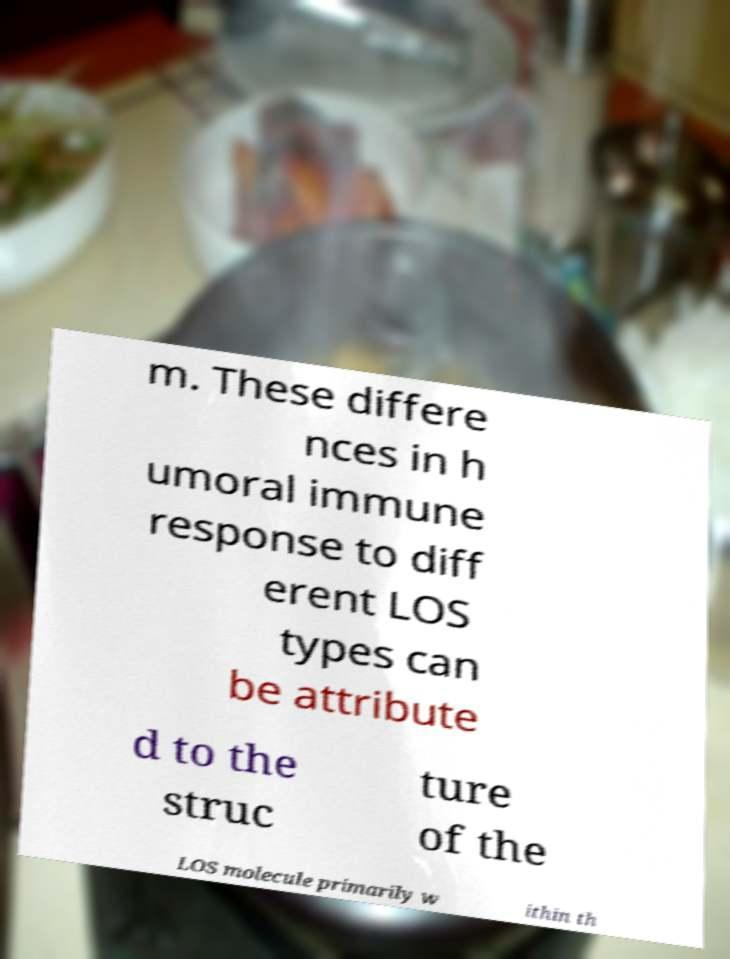I need the written content from this picture converted into text. Can you do that? m. These differe nces in h umoral immune response to diff erent LOS types can be attribute d to the struc ture of the LOS molecule primarily w ithin th 